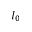<formula> <loc_0><loc_0><loc_500><loc_500>I _ { 0 }</formula> 